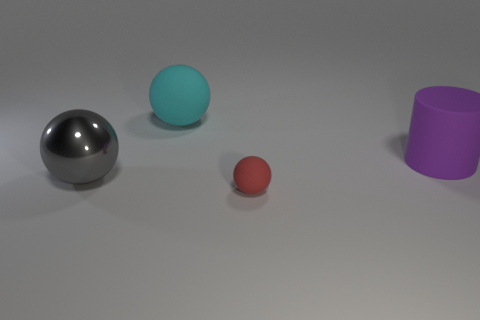Add 3 big gray metal cylinders. How many objects exist? 7 Subtract all balls. How many objects are left? 1 Subtract all gray objects. Subtract all brown shiny cylinders. How many objects are left? 3 Add 2 large gray balls. How many large gray balls are left? 3 Add 3 big cyan things. How many big cyan things exist? 4 Subtract 1 cyan balls. How many objects are left? 3 